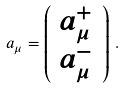Convert formula to latex. <formula><loc_0><loc_0><loc_500><loc_500>a _ { \mu } = \left ( \begin{array} { c } a _ { \mu } ^ { + } \\ a _ { \mu } ^ { - } \end{array} \right ) \, .</formula> 